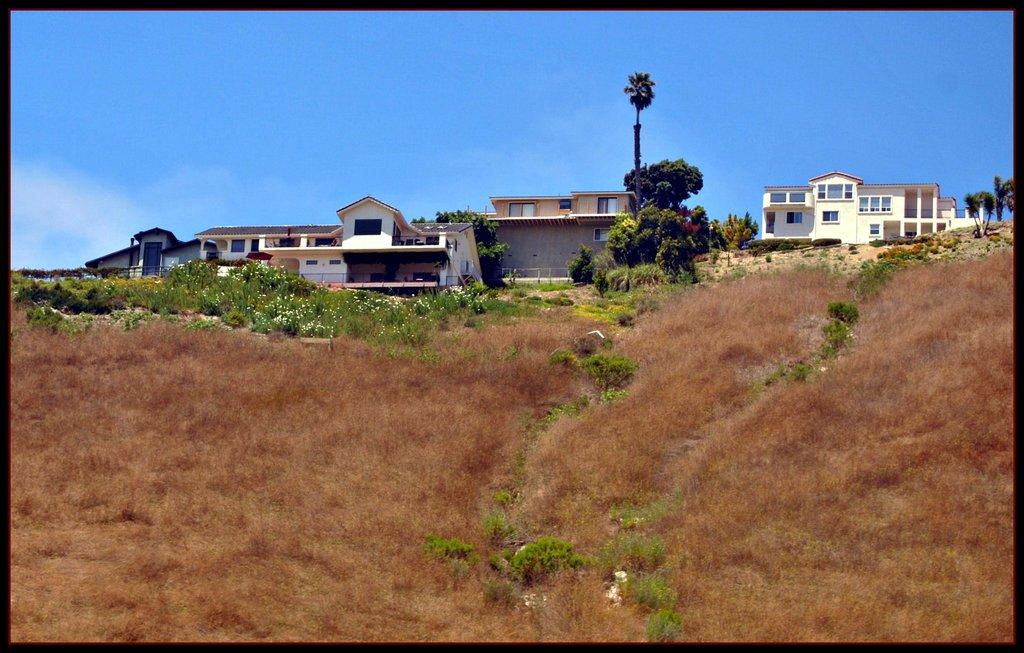What type of structures can be seen in the image? There are houses in the image. What is present between the houses? There are many trees between the houses. What is the landscape feature in the front of the image? There is a large grass surface in the front of the image. What type of crib is visible in the image? There is no crib present in the image. Who is wearing the crown in the image? There is no crown or person wearing a crown in the image. 